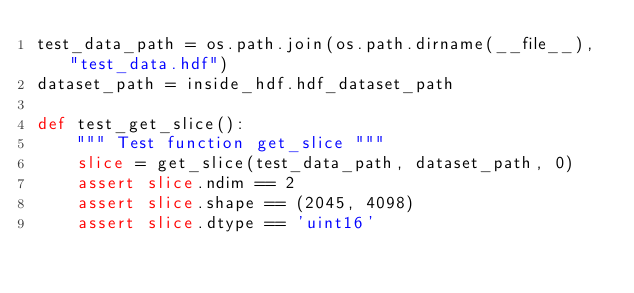<code> <loc_0><loc_0><loc_500><loc_500><_Python_>test_data_path = os.path.join(os.path.dirname(__file__), "test_data.hdf")
dataset_path = inside_hdf.hdf_dataset_path

def test_get_slice():
    """ Test function get_slice """
    slice = get_slice(test_data_path, dataset_path, 0)
    assert slice.ndim == 2
    assert slice.shape == (2045, 4098)
    assert slice.dtype == 'uint16'
</code> 